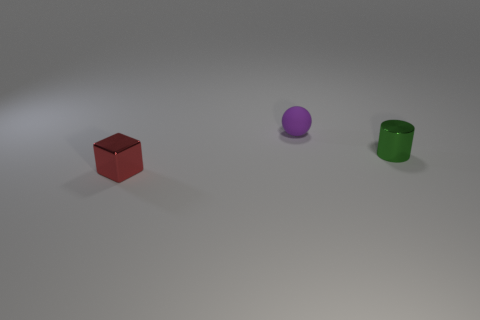Is there any other thing that has the same material as the sphere?
Give a very brief answer. No. There is a object that is to the left of the small purple matte ball; what is its material?
Ensure brevity in your answer.  Metal. Is the number of tiny purple balls on the right side of the purple rubber object the same as the number of big brown metal balls?
Make the answer very short. Yes. What number of small purple things have the same material as the red cube?
Keep it short and to the point. 0. The thing that is made of the same material as the small cylinder is what color?
Your response must be concise. Red. Does the red thing have the same size as the shiny object that is behind the metallic block?
Keep it short and to the point. Yes. The matte thing has what shape?
Ensure brevity in your answer.  Sphere. There is a tiny metallic thing that is to the right of the tiny red block; what number of tiny metal objects are behind it?
Ensure brevity in your answer.  0. How many cylinders are matte objects or red metal objects?
Provide a succinct answer. 0. Is there a small yellow metallic sphere?
Your answer should be compact. No. 